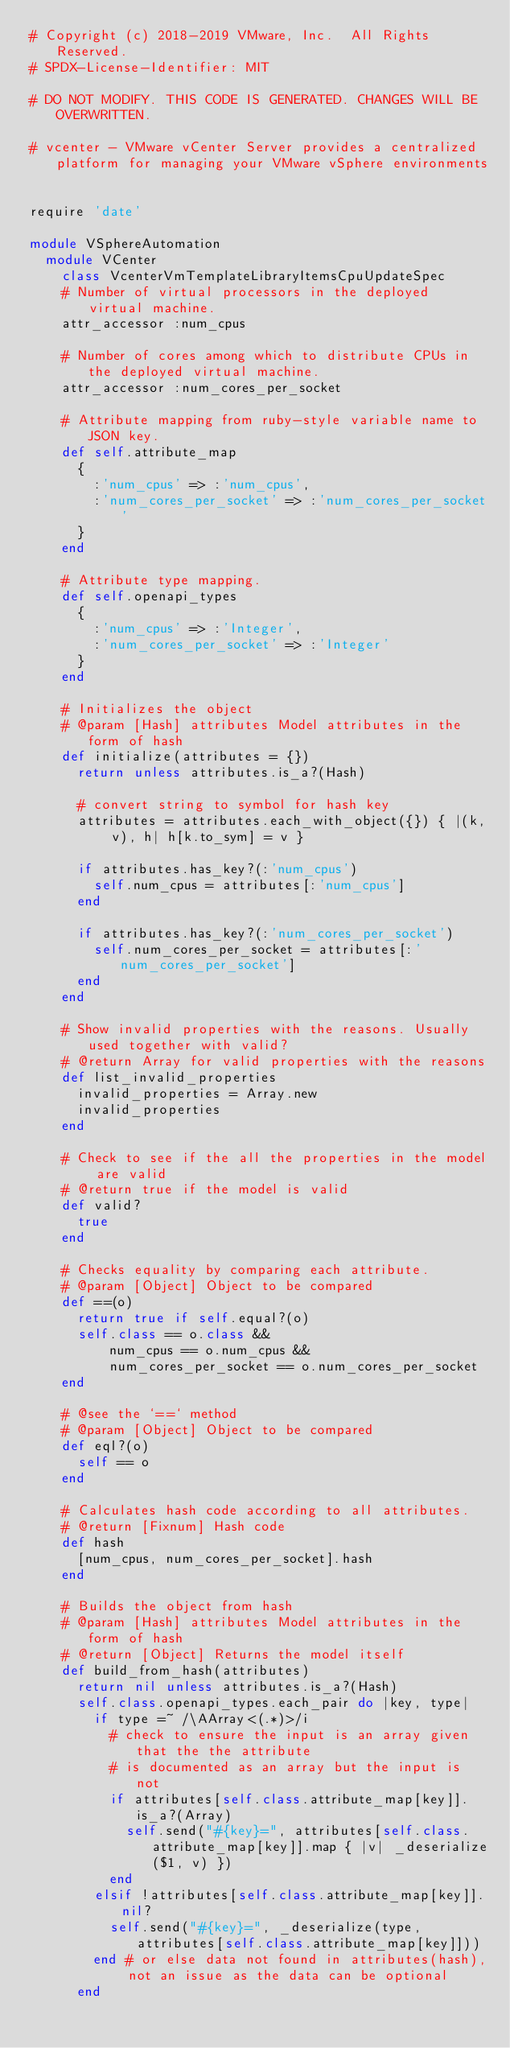Convert code to text. <code><loc_0><loc_0><loc_500><loc_500><_Ruby_># Copyright (c) 2018-2019 VMware, Inc.  All Rights Reserved.
# SPDX-License-Identifier: MIT

# DO NOT MODIFY. THIS CODE IS GENERATED. CHANGES WILL BE OVERWRITTEN.

# vcenter - VMware vCenter Server provides a centralized platform for managing your VMware vSphere environments


require 'date'

module VSphereAutomation
  module VCenter
    class VcenterVmTemplateLibraryItemsCpuUpdateSpec
    # Number of virtual processors in the deployed virtual machine.
    attr_accessor :num_cpus

    # Number of cores among which to distribute CPUs in the deployed virtual machine.
    attr_accessor :num_cores_per_socket

    # Attribute mapping from ruby-style variable name to JSON key.
    def self.attribute_map
      {
        :'num_cpus' => :'num_cpus',
        :'num_cores_per_socket' => :'num_cores_per_socket'
      }
    end

    # Attribute type mapping.
    def self.openapi_types
      {
        :'num_cpus' => :'Integer',
        :'num_cores_per_socket' => :'Integer'
      }
    end

    # Initializes the object
    # @param [Hash] attributes Model attributes in the form of hash
    def initialize(attributes = {})
      return unless attributes.is_a?(Hash)

      # convert string to symbol for hash key
      attributes = attributes.each_with_object({}) { |(k, v), h| h[k.to_sym] = v }

      if attributes.has_key?(:'num_cpus')
        self.num_cpus = attributes[:'num_cpus']
      end

      if attributes.has_key?(:'num_cores_per_socket')
        self.num_cores_per_socket = attributes[:'num_cores_per_socket']
      end
    end

    # Show invalid properties with the reasons. Usually used together with valid?
    # @return Array for valid properties with the reasons
    def list_invalid_properties
      invalid_properties = Array.new
      invalid_properties
    end

    # Check to see if the all the properties in the model are valid
    # @return true if the model is valid
    def valid?
      true
    end

    # Checks equality by comparing each attribute.
    # @param [Object] Object to be compared
    def ==(o)
      return true if self.equal?(o)
      self.class == o.class &&
          num_cpus == o.num_cpus &&
          num_cores_per_socket == o.num_cores_per_socket
    end

    # @see the `==` method
    # @param [Object] Object to be compared
    def eql?(o)
      self == o
    end

    # Calculates hash code according to all attributes.
    # @return [Fixnum] Hash code
    def hash
      [num_cpus, num_cores_per_socket].hash
    end

    # Builds the object from hash
    # @param [Hash] attributes Model attributes in the form of hash
    # @return [Object] Returns the model itself
    def build_from_hash(attributes)
      return nil unless attributes.is_a?(Hash)
      self.class.openapi_types.each_pair do |key, type|
        if type =~ /\AArray<(.*)>/i
          # check to ensure the input is an array given that the the attribute
          # is documented as an array but the input is not
          if attributes[self.class.attribute_map[key]].is_a?(Array)
            self.send("#{key}=", attributes[self.class.attribute_map[key]].map { |v| _deserialize($1, v) })
          end
        elsif !attributes[self.class.attribute_map[key]].nil?
          self.send("#{key}=", _deserialize(type, attributes[self.class.attribute_map[key]]))
        end # or else data not found in attributes(hash), not an issue as the data can be optional
      end
</code> 